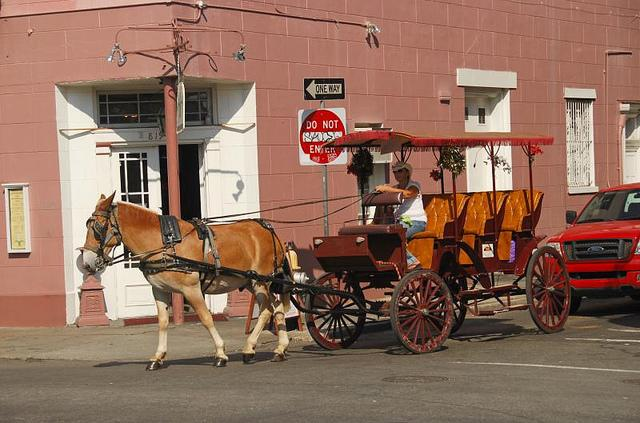What is the person in the carriage most likely looking for? Please explain your reasoning. passengers. The horse needs food and water and that costs money. 